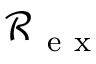<formula> <loc_0><loc_0><loc_500><loc_500>\mathcal { R } _ { e x }</formula> 